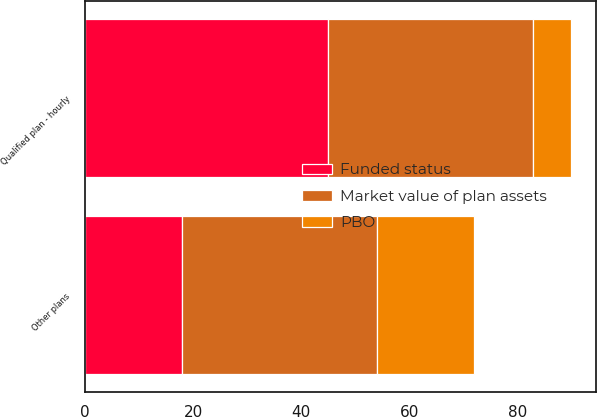<chart> <loc_0><loc_0><loc_500><loc_500><stacked_bar_chart><ecel><fcel>Qualified plan - hourly<fcel>Other plans<nl><fcel>Market value of plan assets<fcel>38<fcel>36<nl><fcel>Funded status<fcel>45<fcel>18<nl><fcel>PBO<fcel>7<fcel>18<nl></chart> 